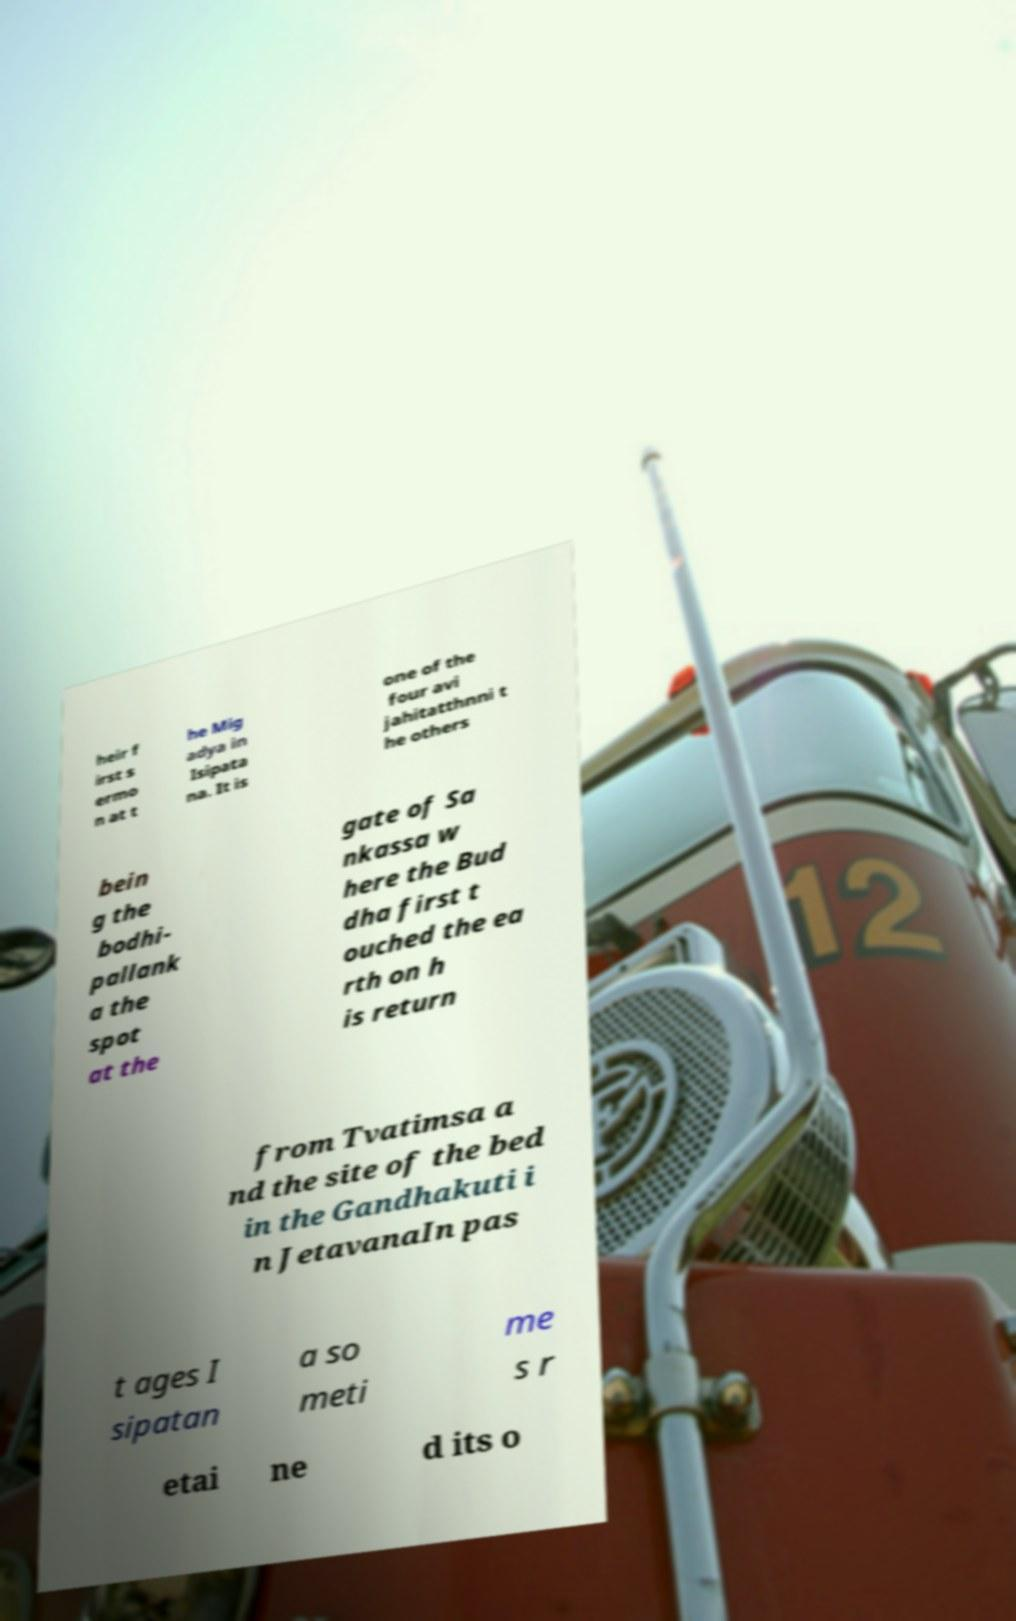Can you read and provide the text displayed in the image?This photo seems to have some interesting text. Can you extract and type it out for me? heir f irst s ermo n at t he Mig adya in Isipata na. It is one of the four avi jahitatthnni t he others bein g the bodhi- pallank a the spot at the gate of Sa nkassa w here the Bud dha first t ouched the ea rth on h is return from Tvatimsa a nd the site of the bed in the Gandhakuti i n JetavanaIn pas t ages I sipatan a so meti me s r etai ne d its o 